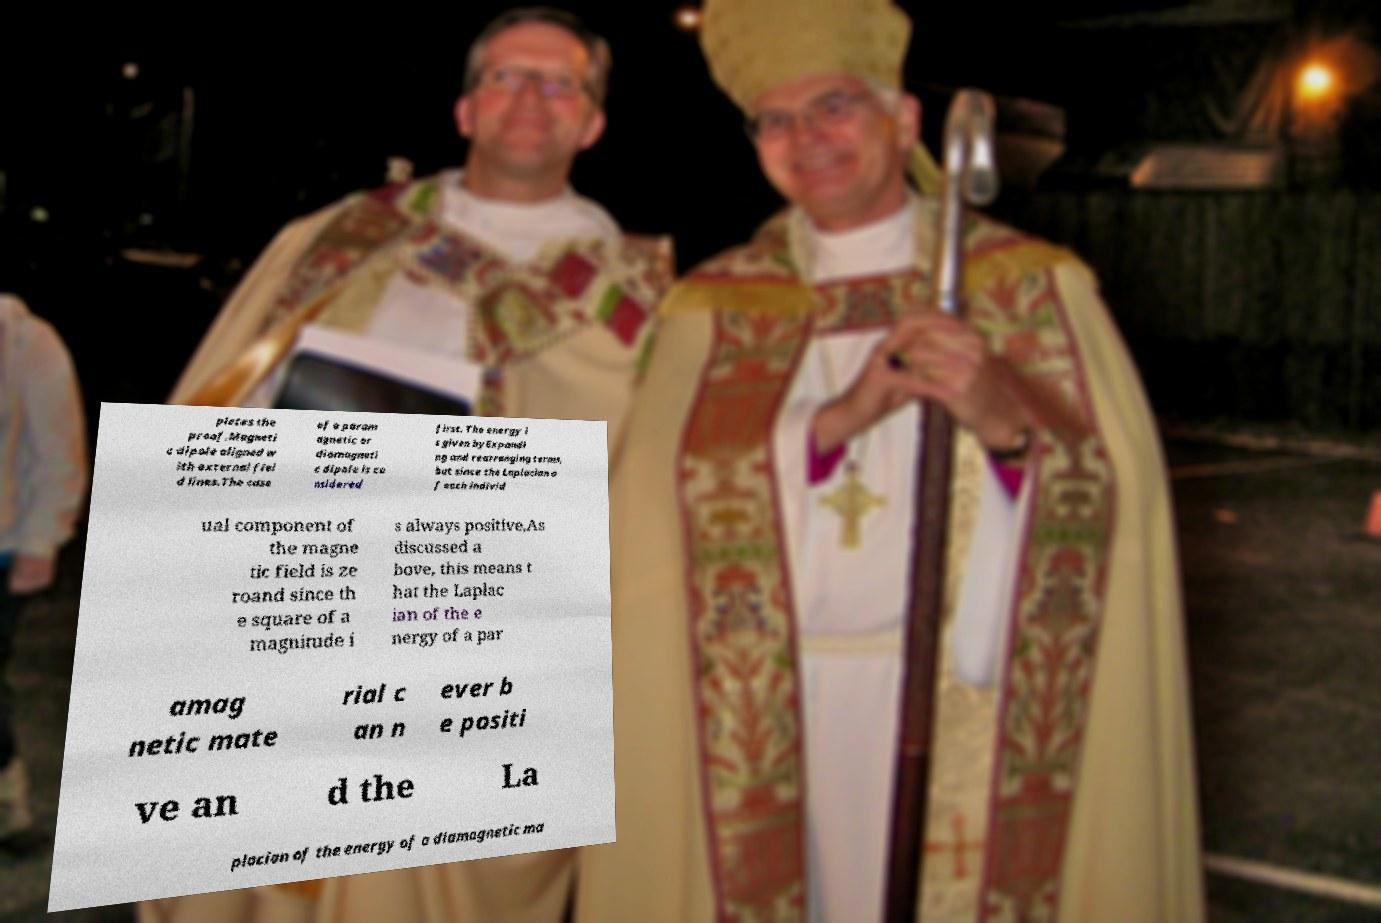Could you extract and type out the text from this image? pletes the proof.Magneti c dipole aligned w ith external fiel d lines.The case of a param agnetic or diamagneti c dipole is co nsidered first. The energy i s given byExpandi ng and rearranging terms, but since the Laplacian o f each individ ual component of the magne tic field is ze roand since th e square of a magnitude i s always positive,As discussed a bove, this means t hat the Laplac ian of the e nergy of a par amag netic mate rial c an n ever b e positi ve an d the La placian of the energy of a diamagnetic ma 